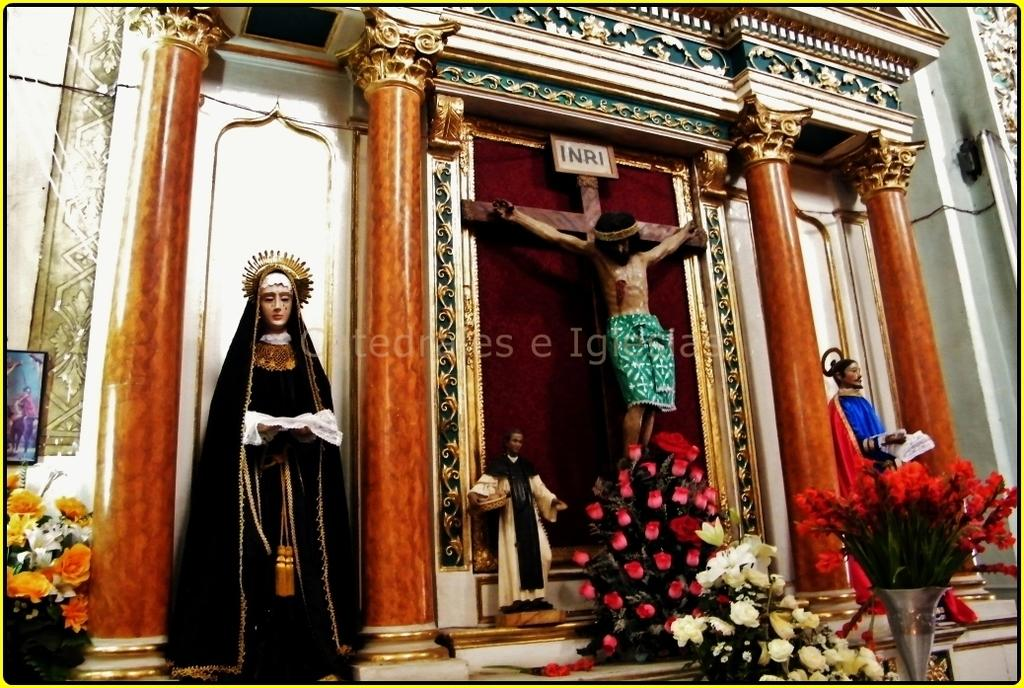<image>
Share a concise interpretation of the image provided. A picture of the Virgin Mary standing next to Christ with the letters INRI above his head. 